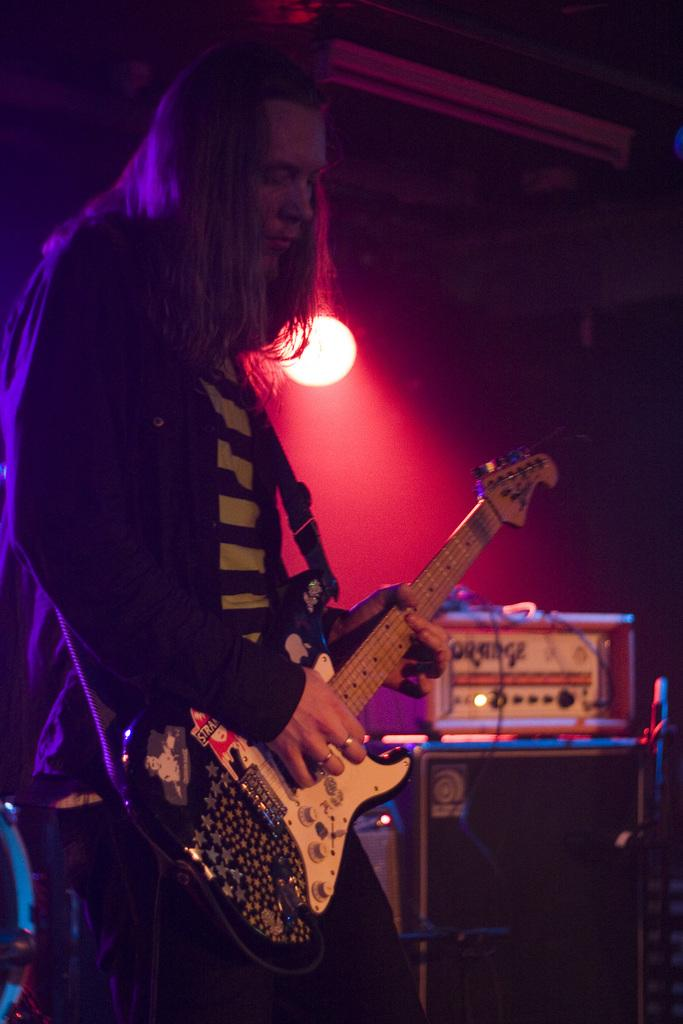Who is the main subject in the image? There is a man in the image. What is the man doing in the image? The man is playing a guitar. Where is the man located in the image? The man is on a stage. What type of copper object can be seen in the image? There is no copper object present in the image. Is the man carrying a bag while playing the guitar? The image does not show the man carrying a bag, so it cannot be determined from the image. 